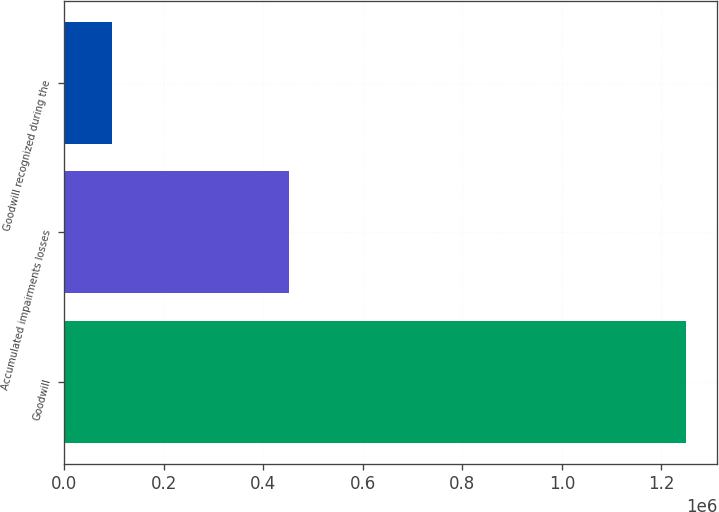Convert chart. <chart><loc_0><loc_0><loc_500><loc_500><bar_chart><fcel>Goodwill<fcel>Accumulated impairments losses<fcel>Goodwill recognized during the<nl><fcel>1.24986e+06<fcel>452441<fcel>95483<nl></chart> 